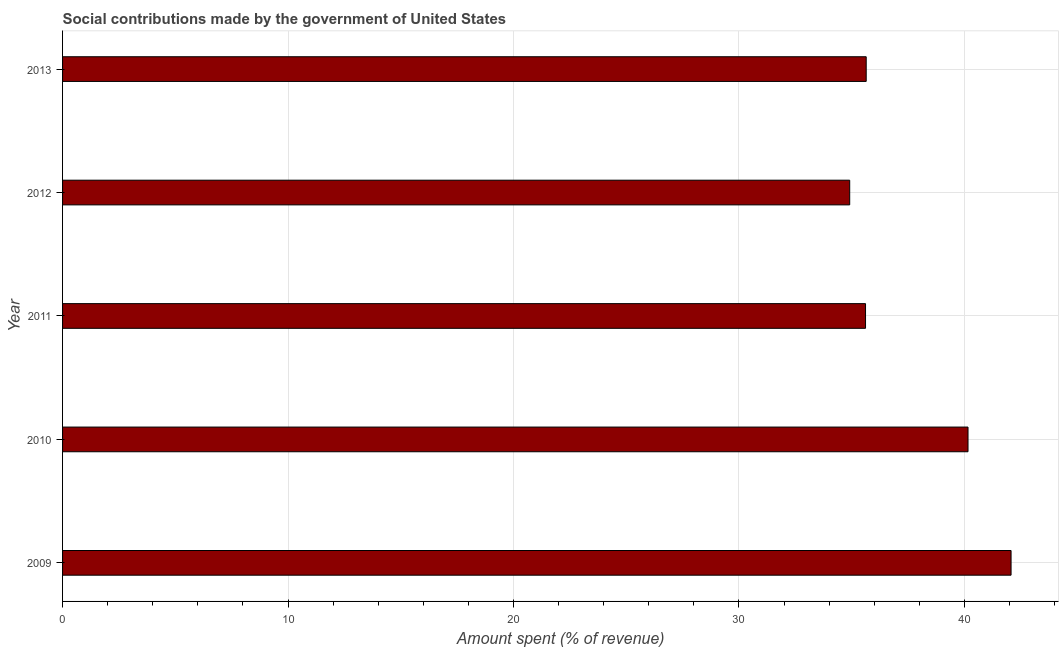What is the title of the graph?
Your answer should be compact. Social contributions made by the government of United States. What is the label or title of the X-axis?
Provide a succinct answer. Amount spent (% of revenue). What is the amount spent in making social contributions in 2012?
Offer a very short reply. 34.91. Across all years, what is the maximum amount spent in making social contributions?
Offer a very short reply. 42.07. Across all years, what is the minimum amount spent in making social contributions?
Give a very brief answer. 34.91. What is the sum of the amount spent in making social contributions?
Ensure brevity in your answer.  188.39. What is the difference between the amount spent in making social contributions in 2011 and 2012?
Provide a succinct answer. 0.7. What is the average amount spent in making social contributions per year?
Give a very brief answer. 37.68. What is the median amount spent in making social contributions?
Your response must be concise. 35.64. In how many years, is the amount spent in making social contributions greater than 42 %?
Provide a short and direct response. 1. Do a majority of the years between 2011 and 2010 (inclusive) have amount spent in making social contributions greater than 6 %?
Your response must be concise. No. What is the difference between the highest and the second highest amount spent in making social contributions?
Offer a terse response. 1.91. Is the sum of the amount spent in making social contributions in 2012 and 2013 greater than the maximum amount spent in making social contributions across all years?
Offer a terse response. Yes. What is the difference between the highest and the lowest amount spent in making social contributions?
Ensure brevity in your answer.  7.16. In how many years, is the amount spent in making social contributions greater than the average amount spent in making social contributions taken over all years?
Offer a terse response. 2. What is the Amount spent (% of revenue) in 2009?
Your answer should be very brief. 42.07. What is the Amount spent (% of revenue) of 2010?
Offer a very short reply. 40.16. What is the Amount spent (% of revenue) in 2011?
Make the answer very short. 35.61. What is the Amount spent (% of revenue) in 2012?
Provide a succinct answer. 34.91. What is the Amount spent (% of revenue) of 2013?
Your answer should be compact. 35.64. What is the difference between the Amount spent (% of revenue) in 2009 and 2010?
Give a very brief answer. 1.91. What is the difference between the Amount spent (% of revenue) in 2009 and 2011?
Make the answer very short. 6.45. What is the difference between the Amount spent (% of revenue) in 2009 and 2012?
Make the answer very short. 7.16. What is the difference between the Amount spent (% of revenue) in 2009 and 2013?
Your answer should be very brief. 6.42. What is the difference between the Amount spent (% of revenue) in 2010 and 2011?
Offer a very short reply. 4.55. What is the difference between the Amount spent (% of revenue) in 2010 and 2012?
Make the answer very short. 5.25. What is the difference between the Amount spent (% of revenue) in 2010 and 2013?
Provide a short and direct response. 4.52. What is the difference between the Amount spent (% of revenue) in 2011 and 2012?
Your answer should be very brief. 0.7. What is the difference between the Amount spent (% of revenue) in 2011 and 2013?
Your answer should be very brief. -0.03. What is the difference between the Amount spent (% of revenue) in 2012 and 2013?
Make the answer very short. -0.73. What is the ratio of the Amount spent (% of revenue) in 2009 to that in 2010?
Your answer should be compact. 1.05. What is the ratio of the Amount spent (% of revenue) in 2009 to that in 2011?
Give a very brief answer. 1.18. What is the ratio of the Amount spent (% of revenue) in 2009 to that in 2012?
Keep it short and to the point. 1.21. What is the ratio of the Amount spent (% of revenue) in 2009 to that in 2013?
Make the answer very short. 1.18. What is the ratio of the Amount spent (% of revenue) in 2010 to that in 2011?
Keep it short and to the point. 1.13. What is the ratio of the Amount spent (% of revenue) in 2010 to that in 2012?
Provide a short and direct response. 1.15. What is the ratio of the Amount spent (% of revenue) in 2010 to that in 2013?
Your response must be concise. 1.13. What is the ratio of the Amount spent (% of revenue) in 2011 to that in 2012?
Offer a very short reply. 1.02. 